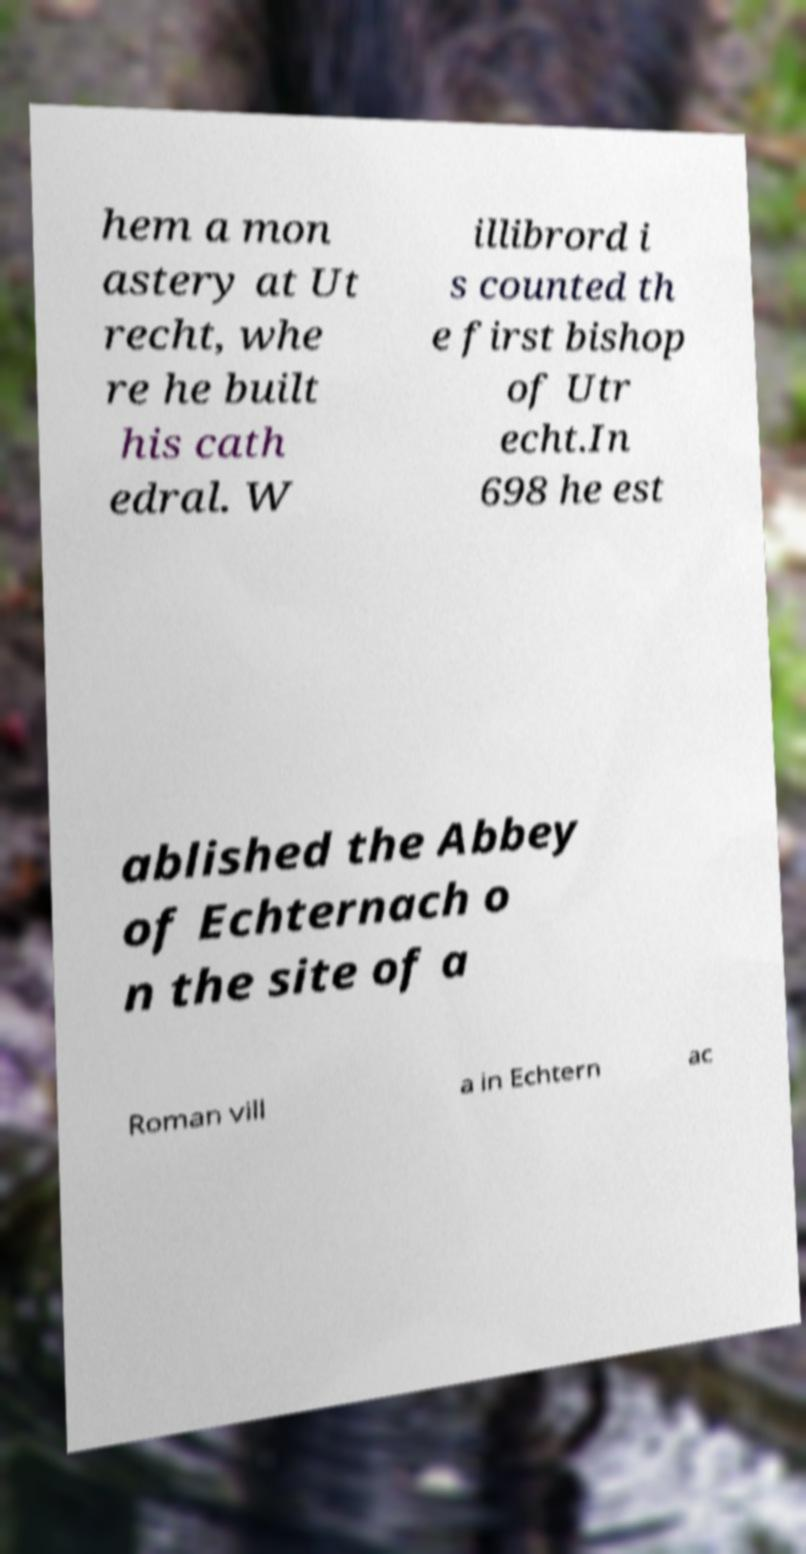Could you assist in decoding the text presented in this image and type it out clearly? hem a mon astery at Ut recht, whe re he built his cath edral. W illibrord i s counted th e first bishop of Utr echt.In 698 he est ablished the Abbey of Echternach o n the site of a Roman vill a in Echtern ac 